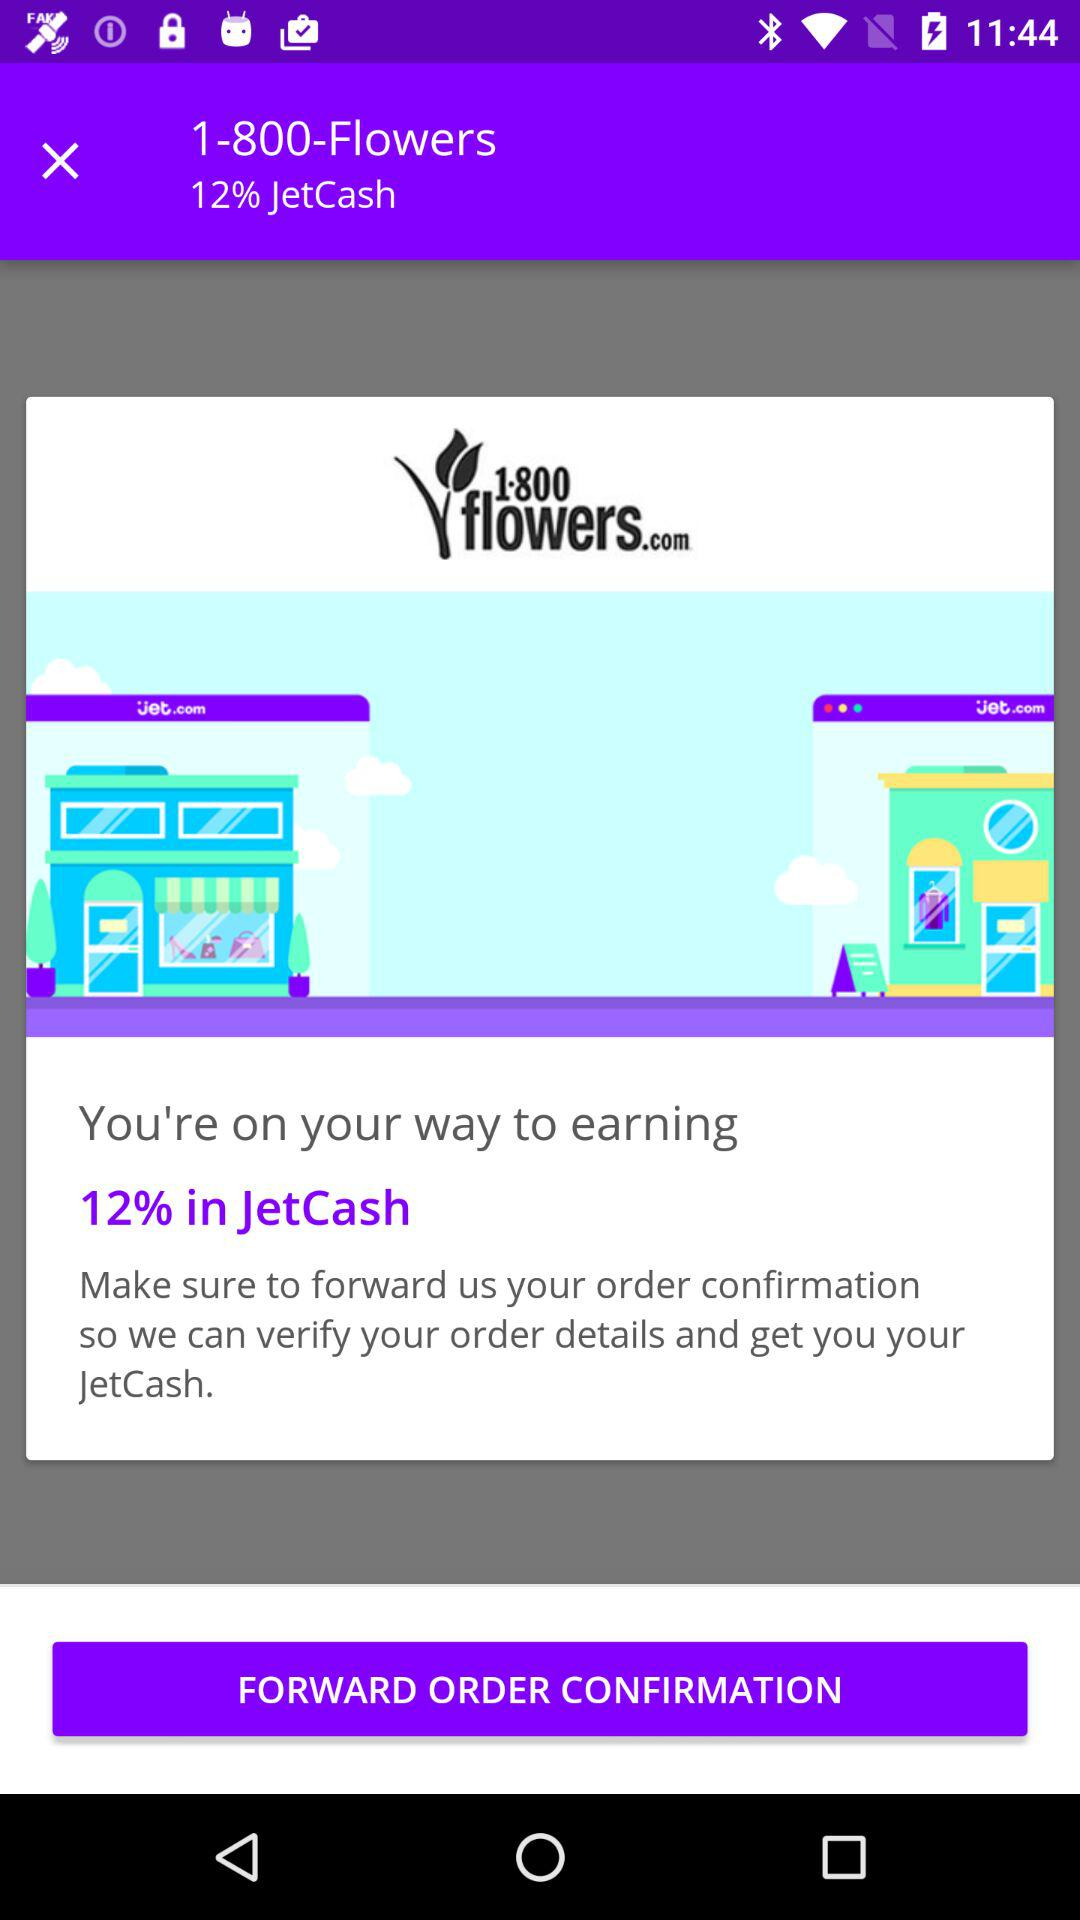What is the application name? The name of the application is "1800 Flowers". 